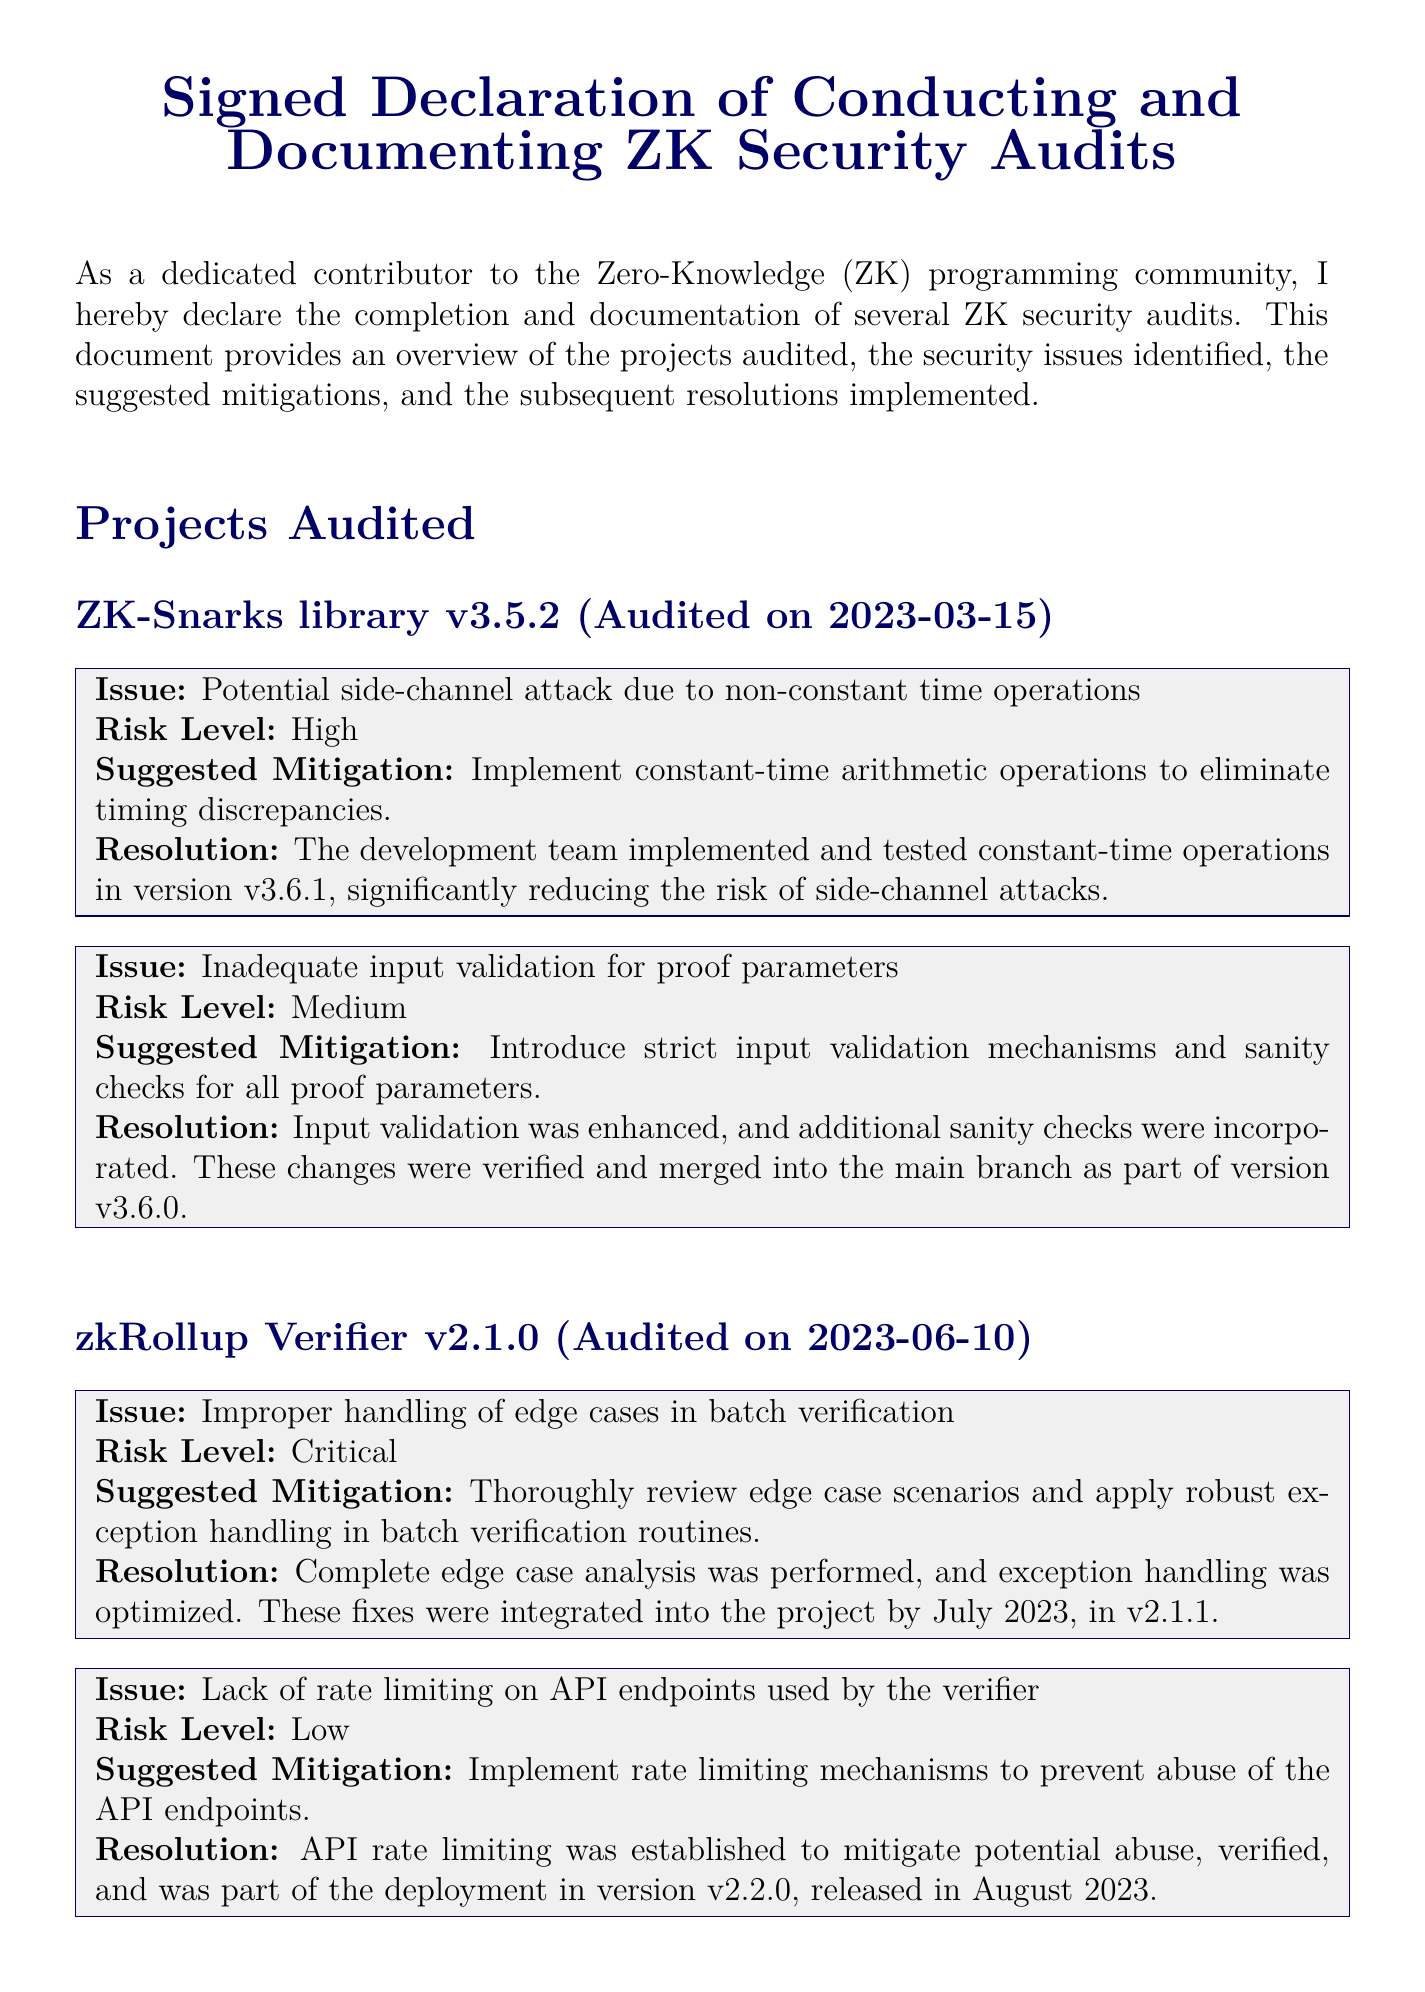What is the title of the document? The title appears at the top of the document, highlighting its purpose regarding ZK security audits.
Answer: Signed Declaration of Conducting and Documenting ZK Security Audits Who is the author of the document? The author is identified in the signature section at the bottom of the document.
Answer: John Doe When was the ZK-Snarks library audited? The audit date for this project is specified directly after the project name in the document.
Answer: 2023-03-15 What major issue was found in the zkRollup Verifier? The major issue is listed under the section for this project and relates to batch verification.
Answer: Improper handling of edge cases in batch verification What risk level was assigned to the input validation issue? The risk level of this issue is indicated in the respective issue block.
Answer: Medium Which version of the ZK-Snarks library fixed the timing attack issue? The resolution section of the issue block provides the version where the fix was implemented.
Answer: v3.6.1 What kind of mitigation was suggested for the lack of rate limiting? The suggested mitigation is detailed in the document within the relevant issue block for the project.
Answer: Implement rate limiting mechanisms When was the last audit conducted? The last audit date can be determined by looking at the most recent project audited in the document.
Answer: 2023-06-10 What is the title of the author? The title is noted in the signature area of the document.
Answer: Senior ZK Developer What was the release version that integrated the exception handling fixes? The version that included these fixes is stated in the resolution section of the issue block for the project.
Answer: v2.1.1 